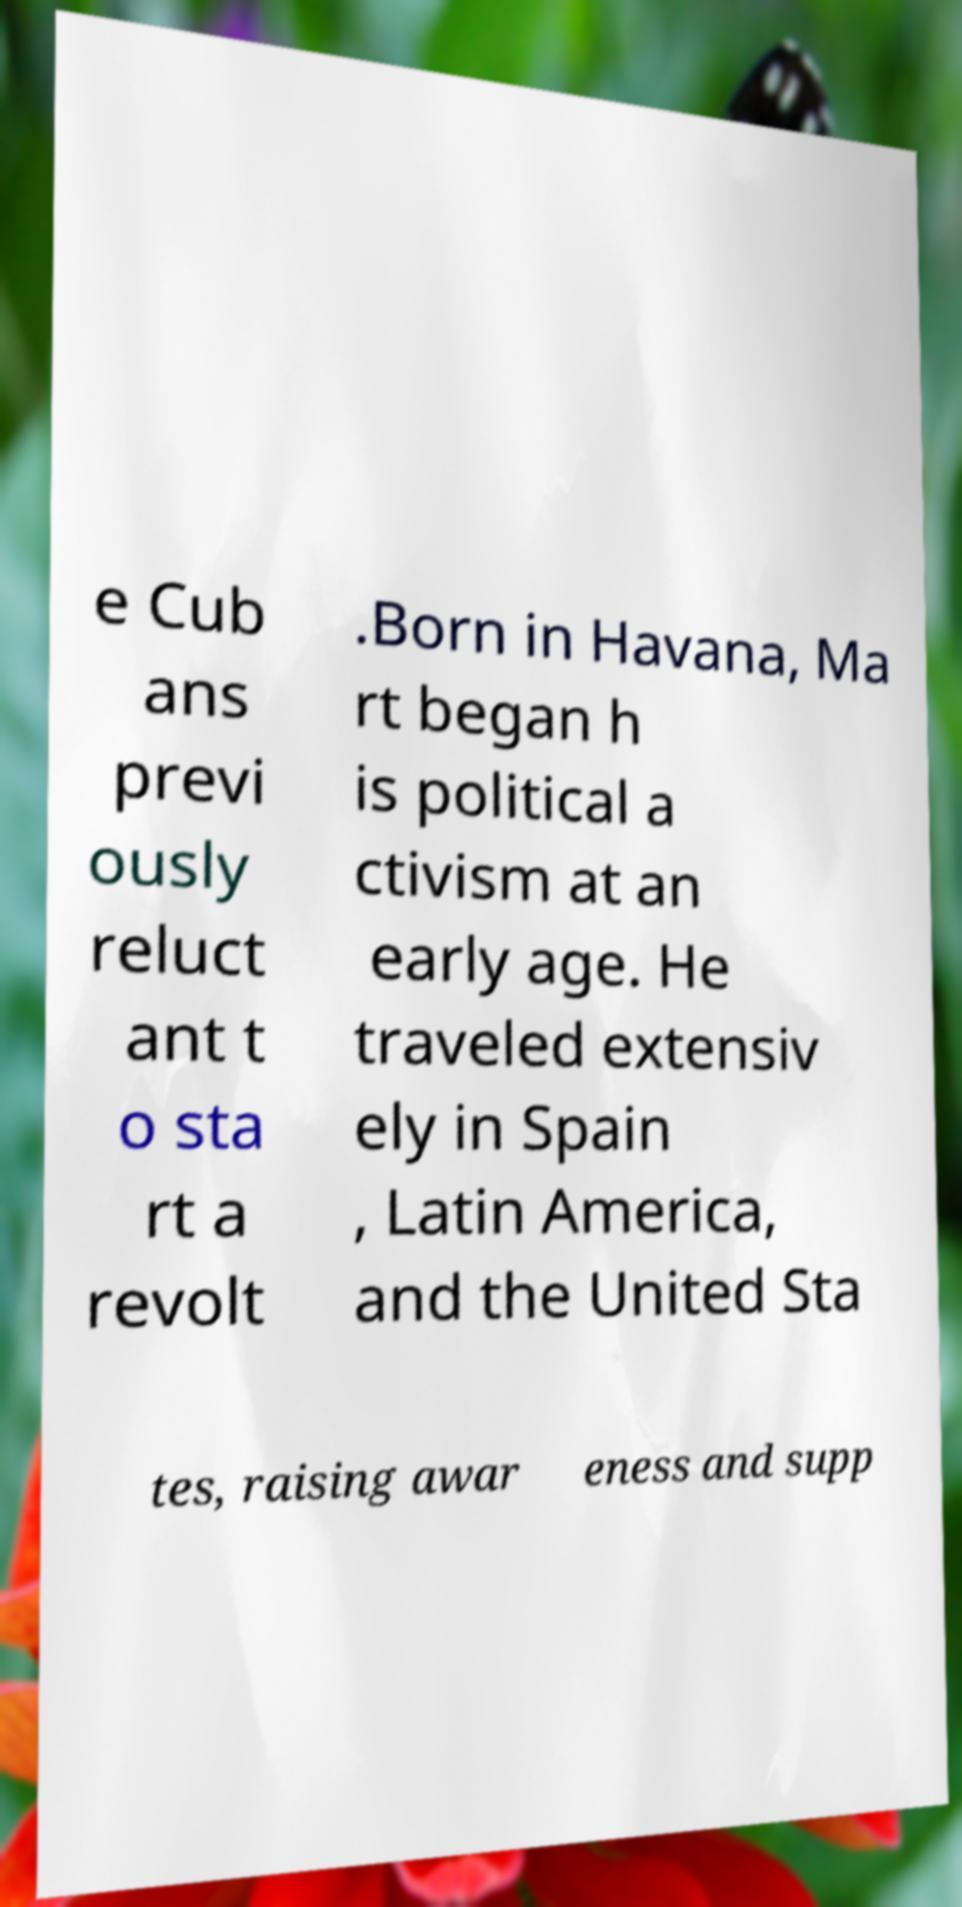What messages or text are displayed in this image? I need them in a readable, typed format. e Cub ans previ ously reluct ant t o sta rt a revolt .Born in Havana, Ma rt began h is political a ctivism at an early age. He traveled extensiv ely in Spain , Latin America, and the United Sta tes, raising awar eness and supp 